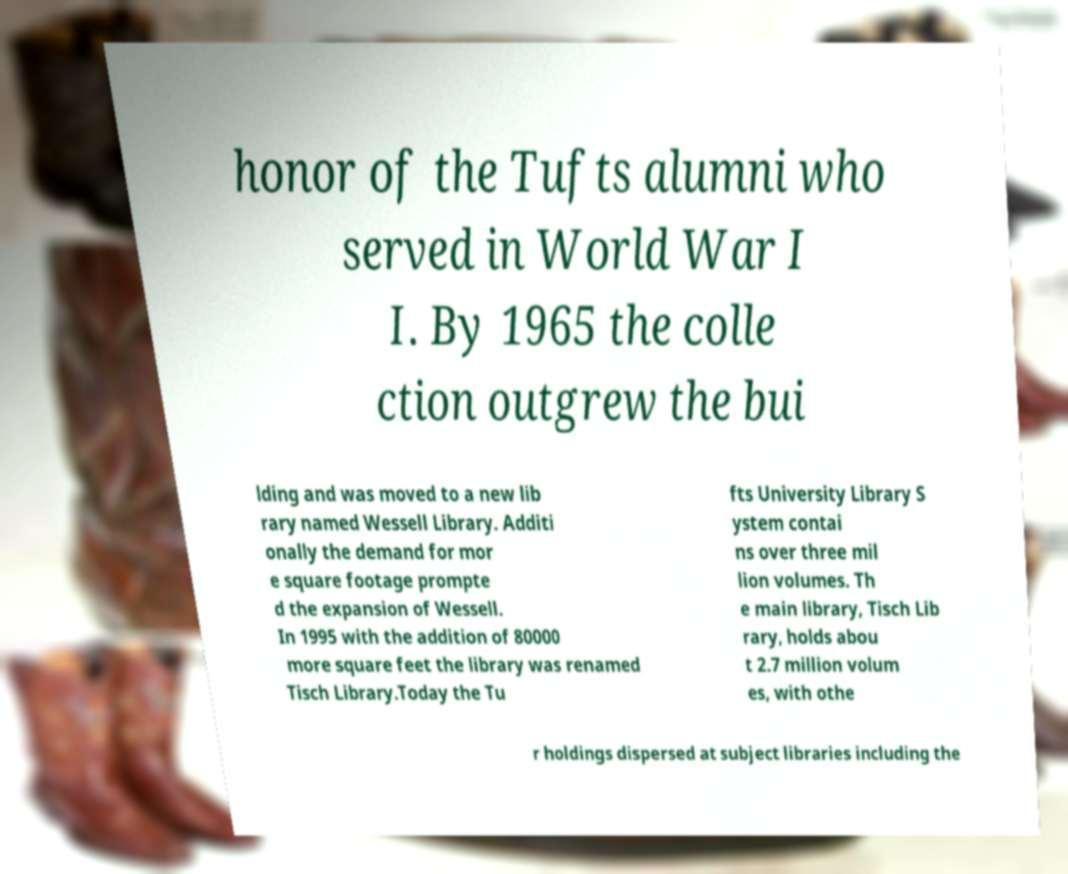I need the written content from this picture converted into text. Can you do that? honor of the Tufts alumni who served in World War I I. By 1965 the colle ction outgrew the bui lding and was moved to a new lib rary named Wessell Library. Additi onally the demand for mor e square footage prompte d the expansion of Wessell. In 1995 with the addition of 80000 more square feet the library was renamed Tisch Library.Today the Tu fts University Library S ystem contai ns over three mil lion volumes. Th e main library, Tisch Lib rary, holds abou t 2.7 million volum es, with othe r holdings dispersed at subject libraries including the 